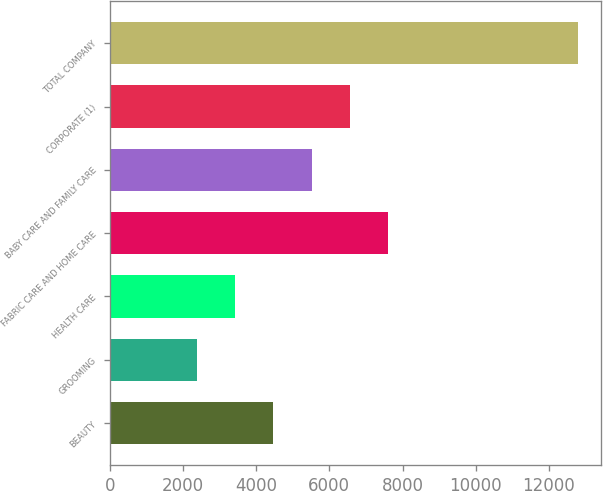Convert chart to OTSL. <chart><loc_0><loc_0><loc_500><loc_500><bar_chart><fcel>BEAUTY<fcel>GROOMING<fcel>HEALTH CARE<fcel>FABRIC CARE AND HOME CARE<fcel>BABY CARE AND FAMILY CARE<fcel>CORPORATE (1)<fcel>TOTAL COMPANY<nl><fcel>4473<fcel>2395<fcel>3434<fcel>7590<fcel>5512<fcel>6551<fcel>12785<nl></chart> 